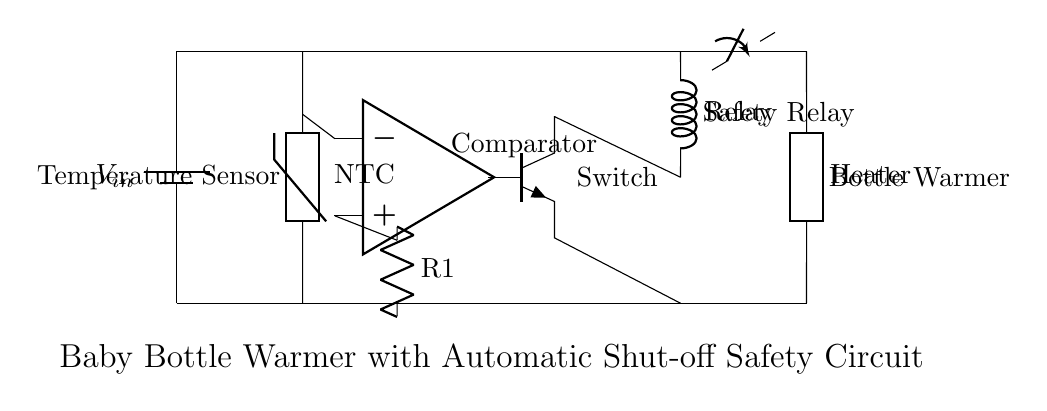What type of thermistor is used in this circuit? The circuit shows an NTC thermistor labeled as "NTC", which stands for Negative Temperature Coefficient. This type of thermistor decreases in resistance as the temperature increases.
Answer: NTC What component detects the temperature? The temperature sensor in the circuit is identified as a thermistor, specifically an NTC thermistor, which is responsible for sensing the temperature of the liquid in the bottle.
Answer: Thermistor How does the automatic shut-off feature work? The automatic shut-off feature operates through a comparator connected to the thermistor. It compares the temperature reading from the thermistor with a set reference voltage. When the desired temperature is reached, the output of the comparator signals the transistor to turn off, thus deactivating the heating element.
Answer: Comparator What type of switch is indicated in the circuit? The switch present in the circuit is a relay, which is a type of switch controlled by an electromagnet, allowing high power devices like the heater to turn on or off in response to a low power signal from the transistor.
Answer: Relay Which component activates the heating element? The heating element is activated when the relay closes the circuit, allowing current to flow through it. This activation is controlled by the transistor, which receives signals from the comparator based on the temperature sensed by the thermistor.
Answer: Transistor What happens when the temperature exceeds the set limit? When the temperature exceeds the predetermined limit, the comparator's output changes state, turning off the transistor, which then opens the relay switch and stops power to the heating element, protecting against overheating.
Answer: Heating element turns off 